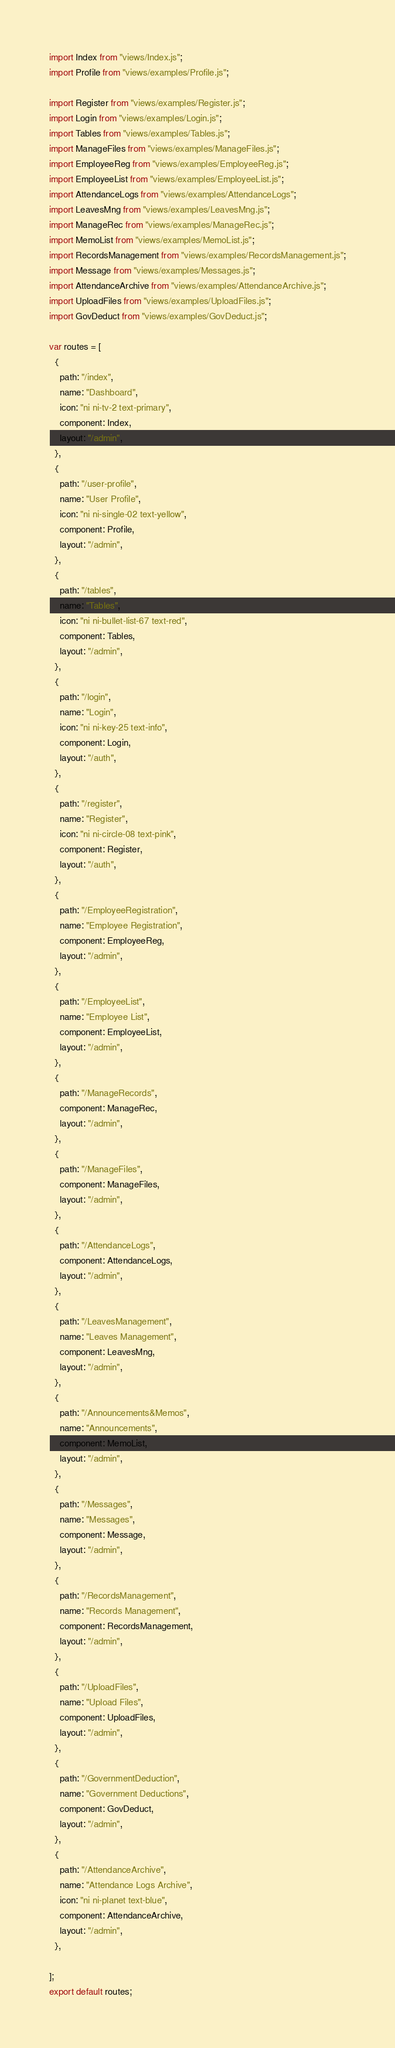<code> <loc_0><loc_0><loc_500><loc_500><_JavaScript_>import Index from "views/Index.js";
import Profile from "views/examples/Profile.js";

import Register from "views/examples/Register.js";
import Login from "views/examples/Login.js";
import Tables from "views/examples/Tables.js";
import ManageFiles from "views/examples/ManageFiles.js";
import EmployeeReg from "views/examples/EmployeeReg.js";
import EmployeeList from "views/examples/EmployeeList.js";
import AttendanceLogs from "views/examples/AttendanceLogs";
import LeavesMng from "views/examples/LeavesMng.js";
import ManageRec from "views/examples/ManageRec.js";
import MemoList from "views/examples/MemoList.js";
import RecordsManagement from "views/examples/RecordsManagement.js";
import Message from "views/examples/Messages.js";
import AttendanceArchive from "views/examples/AttendanceArchive.js";
import UploadFiles from "views/examples/UploadFiles.js";
import GovDeduct from "views/examples/GovDeduct.js";

var routes = [
  {
    path: "/index",
    name: "Dashboard",
    icon: "ni ni-tv-2 text-primary",
    component: Index,
    layout: "/admin",
  },
  {
    path: "/user-profile",
    name: "User Profile",
    icon: "ni ni-single-02 text-yellow",
    component: Profile,
    layout: "/admin",
  },
  {
    path: "/tables",
    name: "Tables",
    icon: "ni ni-bullet-list-67 text-red",
    component: Tables,
    layout: "/admin",
  },
  {
    path: "/login",
    name: "Login",
    icon: "ni ni-key-25 text-info",
    component: Login,
    layout: "/auth",
  },
  {
    path: "/register",
    name: "Register",
    icon: "ni ni-circle-08 text-pink",
    component: Register,
    layout: "/auth",
  },
  {
    path: "/EmployeeRegistration",
    name: "Employee Registration",
    component: EmployeeReg,
    layout: "/admin",
  },
  {
    path: "/EmployeeList",
    name: "Employee List",
    component: EmployeeList,
    layout: "/admin",
  },
  {
    path: "/ManageRecords",
    component: ManageRec,
    layout: "/admin",
  },
  {
    path: "/ManageFiles",
    component: ManageFiles,
    layout: "/admin",
  },
  {
    path: "/AttendanceLogs",
    component: AttendanceLogs,
    layout: "/admin",
  },
  {
    path: "/LeavesManagement",
    name: "Leaves Management",
    component: LeavesMng,
    layout: "/admin",
  },
  {
    path: "/Announcements&Memos",
    name: "Announcements",
    component: MemoList,
    layout: "/admin",
  },
  {
    path: "/Messages",
    name: "Messages",
    component: Message,
    layout: "/admin",
  },
  {
    path: "/RecordsManagement",
    name: "Records Management",
    component: RecordsManagement,
    layout: "/admin",
  },
  {
    path: "/UploadFiles",
    name: "Upload Files",
    component: UploadFiles,
    layout: "/admin",
  },
  {
    path: "/GovernmentDeduction",
    name: "Government Deductions",
    component: GovDeduct,
    layout: "/admin",
  },
  {
    path: "/AttendanceArchive",
    name: "Attendance Logs Archive",
    icon: "ni ni-planet text-blue",
    component: AttendanceArchive,
    layout: "/admin",
  },

];
export default routes;
</code> 